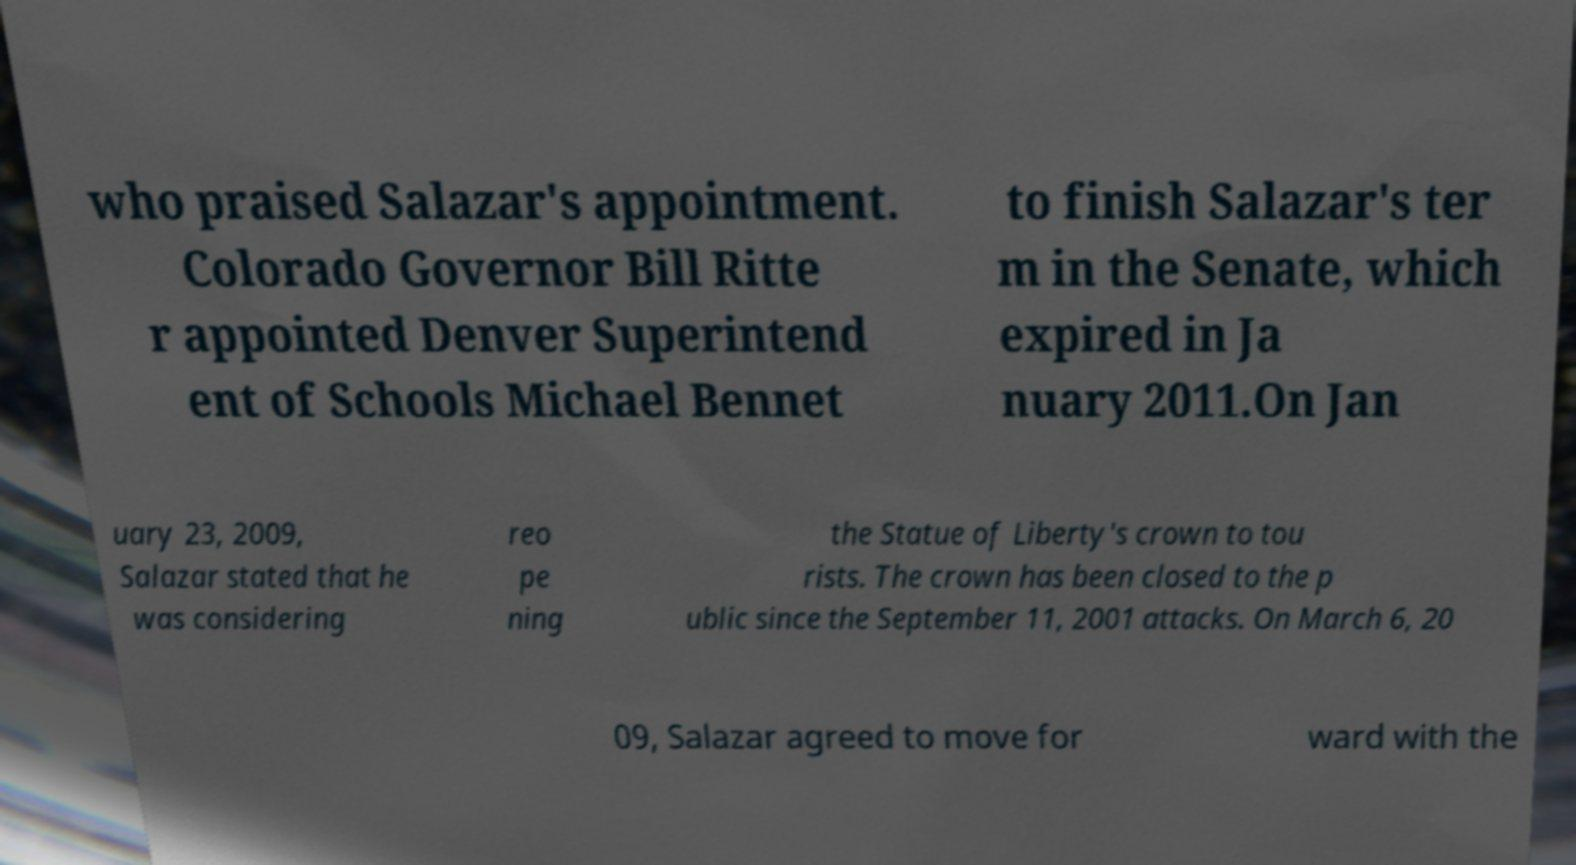For documentation purposes, I need the text within this image transcribed. Could you provide that? who praised Salazar's appointment. Colorado Governor Bill Ritte r appointed Denver Superintend ent of Schools Michael Bennet to finish Salazar's ter m in the Senate, which expired in Ja nuary 2011.On Jan uary 23, 2009, Salazar stated that he was considering reo pe ning the Statue of Liberty's crown to tou rists. The crown has been closed to the p ublic since the September 11, 2001 attacks. On March 6, 20 09, Salazar agreed to move for ward with the 